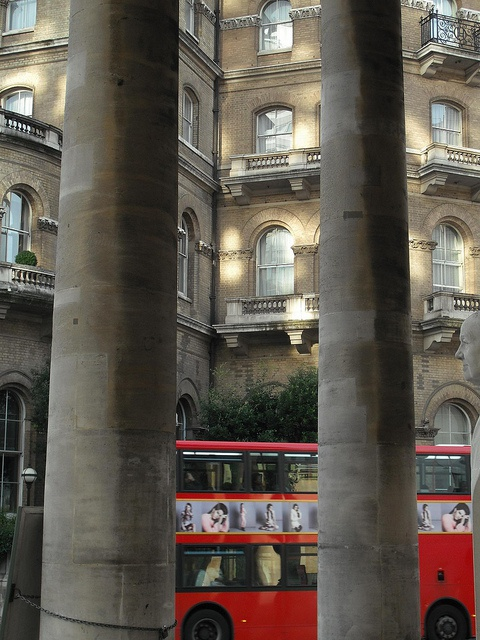Describe the objects in this image and their specific colors. I can see bus in gray, black, brown, and darkgray tones in this image. 